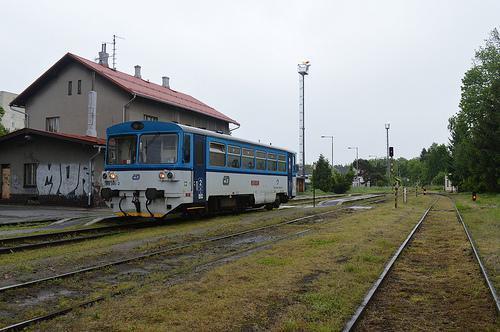How many trains are in the picture?
Give a very brief answer. 1. 